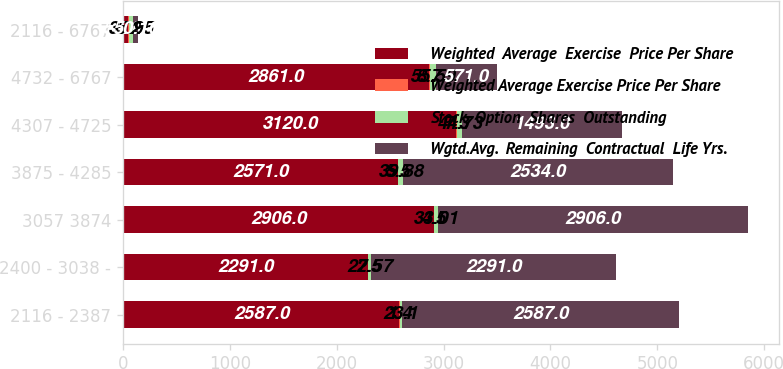Convert chart to OTSL. <chart><loc_0><loc_0><loc_500><loc_500><stacked_bar_chart><ecel><fcel>2116 - 2387<fcel>2400 - 3038 -<fcel>3057 3874<fcel>3875 - 4285<fcel>4307 - 4725<fcel>4732 - 6767<fcel>2116 - 6767<nl><fcel>Weighted  Average  Exercise  Price Per Share<fcel>2587<fcel>2291<fcel>2906<fcel>2571<fcel>3120<fcel>2861<fcel>50.16<nl><fcel>Weighted Average Exercise Price Per Share<fcel>1.4<fcel>2.5<fcel>4.5<fcel>5.5<fcel>7.3<fcel>8.7<fcel>5.2<nl><fcel>Stock  Option  Shares  Outstanding<fcel>23.1<fcel>27.57<fcel>33.01<fcel>39.88<fcel>44.73<fcel>55.59<fcel>37.95<nl><fcel>Wgtd.Avg.  Remaining  Contractual  Life Yrs.<fcel>2587<fcel>2291<fcel>2906<fcel>2534<fcel>1493<fcel>571<fcel>50.16<nl></chart> 